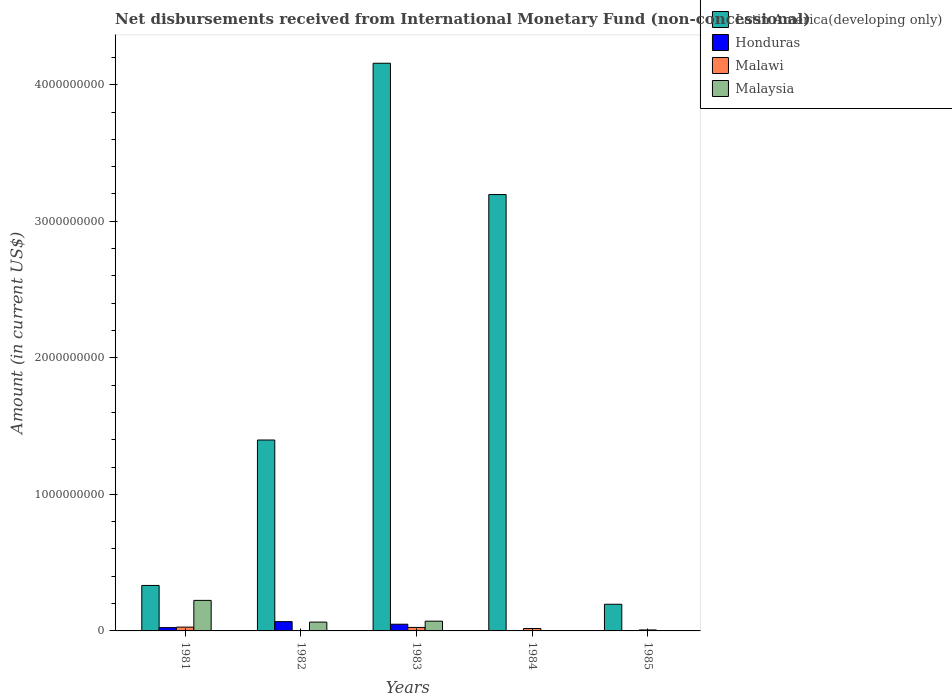How many different coloured bars are there?
Provide a succinct answer. 4. Are the number of bars per tick equal to the number of legend labels?
Your answer should be very brief. No. What is the label of the 1st group of bars from the left?
Provide a short and direct response. 1981. What is the amount of disbursements received from International Monetary Fund in Malaysia in 1982?
Offer a terse response. 6.46e+07. Across all years, what is the maximum amount of disbursements received from International Monetary Fund in Latin America(developing only)?
Provide a short and direct response. 4.16e+09. Across all years, what is the minimum amount of disbursements received from International Monetary Fund in Latin America(developing only)?
Ensure brevity in your answer.  1.95e+08. What is the total amount of disbursements received from International Monetary Fund in Honduras in the graph?
Your response must be concise. 1.41e+08. What is the difference between the amount of disbursements received from International Monetary Fund in Latin America(developing only) in 1982 and that in 1985?
Make the answer very short. 1.20e+09. What is the difference between the amount of disbursements received from International Monetary Fund in Latin America(developing only) in 1983 and the amount of disbursements received from International Monetary Fund in Honduras in 1985?
Ensure brevity in your answer.  4.16e+09. What is the average amount of disbursements received from International Monetary Fund in Malaysia per year?
Provide a short and direct response. 7.19e+07. In the year 1982, what is the difference between the amount of disbursements received from International Monetary Fund in Latin America(developing only) and amount of disbursements received from International Monetary Fund in Malaysia?
Give a very brief answer. 1.33e+09. What is the ratio of the amount of disbursements received from International Monetary Fund in Latin America(developing only) in 1981 to that in 1984?
Offer a terse response. 0.1. Is the amount of disbursements received from International Monetary Fund in Malawi in 1983 less than that in 1984?
Ensure brevity in your answer.  No. What is the difference between the highest and the second highest amount of disbursements received from International Monetary Fund in Latin America(developing only)?
Offer a terse response. 9.61e+08. What is the difference between the highest and the lowest amount of disbursements received from International Monetary Fund in Malaysia?
Your answer should be very brief. 2.24e+08. Is it the case that in every year, the sum of the amount of disbursements received from International Monetary Fund in Malaysia and amount of disbursements received from International Monetary Fund in Malawi is greater than the sum of amount of disbursements received from International Monetary Fund in Honduras and amount of disbursements received from International Monetary Fund in Latin America(developing only)?
Make the answer very short. No. Is it the case that in every year, the sum of the amount of disbursements received from International Monetary Fund in Malawi and amount of disbursements received from International Monetary Fund in Malaysia is greater than the amount of disbursements received from International Monetary Fund in Latin America(developing only)?
Keep it short and to the point. No. Are all the bars in the graph horizontal?
Offer a very short reply. No. How many years are there in the graph?
Make the answer very short. 5. What is the difference between two consecutive major ticks on the Y-axis?
Provide a short and direct response. 1.00e+09. Are the values on the major ticks of Y-axis written in scientific E-notation?
Offer a terse response. No. Does the graph contain any zero values?
Keep it short and to the point. Yes. Does the graph contain grids?
Offer a terse response. No. What is the title of the graph?
Ensure brevity in your answer.  Net disbursements received from International Monetary Fund (non-concessional). Does "Tonga" appear as one of the legend labels in the graph?
Offer a very short reply. No. What is the label or title of the Y-axis?
Make the answer very short. Amount (in current US$). What is the Amount (in current US$) in Latin America(developing only) in 1981?
Keep it short and to the point. 3.33e+08. What is the Amount (in current US$) in Honduras in 1981?
Your answer should be compact. 2.43e+07. What is the Amount (in current US$) of Malawi in 1981?
Provide a short and direct response. 2.79e+07. What is the Amount (in current US$) of Malaysia in 1981?
Offer a terse response. 2.24e+08. What is the Amount (in current US$) in Latin America(developing only) in 1982?
Make the answer very short. 1.40e+09. What is the Amount (in current US$) in Honduras in 1982?
Make the answer very short. 6.81e+07. What is the Amount (in current US$) in Malawi in 1982?
Provide a succinct answer. 0. What is the Amount (in current US$) of Malaysia in 1982?
Your answer should be compact. 6.46e+07. What is the Amount (in current US$) in Latin America(developing only) in 1983?
Give a very brief answer. 4.16e+09. What is the Amount (in current US$) in Honduras in 1983?
Offer a terse response. 4.91e+07. What is the Amount (in current US$) of Malawi in 1983?
Keep it short and to the point. 2.56e+07. What is the Amount (in current US$) of Malaysia in 1983?
Offer a very short reply. 7.14e+07. What is the Amount (in current US$) of Latin America(developing only) in 1984?
Ensure brevity in your answer.  3.20e+09. What is the Amount (in current US$) of Malawi in 1984?
Offer a terse response. 1.78e+07. What is the Amount (in current US$) of Latin America(developing only) in 1985?
Your answer should be compact. 1.95e+08. What is the Amount (in current US$) in Malawi in 1985?
Keep it short and to the point. 7.20e+06. What is the Amount (in current US$) of Malaysia in 1985?
Keep it short and to the point. 0. Across all years, what is the maximum Amount (in current US$) of Latin America(developing only)?
Keep it short and to the point. 4.16e+09. Across all years, what is the maximum Amount (in current US$) in Honduras?
Offer a terse response. 6.81e+07. Across all years, what is the maximum Amount (in current US$) in Malawi?
Offer a very short reply. 2.79e+07. Across all years, what is the maximum Amount (in current US$) in Malaysia?
Your answer should be very brief. 2.24e+08. Across all years, what is the minimum Amount (in current US$) of Latin America(developing only)?
Offer a very short reply. 1.95e+08. Across all years, what is the minimum Amount (in current US$) of Honduras?
Your answer should be compact. 0. Across all years, what is the minimum Amount (in current US$) in Malaysia?
Offer a very short reply. 0. What is the total Amount (in current US$) in Latin America(developing only) in the graph?
Offer a very short reply. 9.28e+09. What is the total Amount (in current US$) in Honduras in the graph?
Your answer should be very brief. 1.41e+08. What is the total Amount (in current US$) of Malawi in the graph?
Give a very brief answer. 7.85e+07. What is the total Amount (in current US$) of Malaysia in the graph?
Your response must be concise. 3.60e+08. What is the difference between the Amount (in current US$) of Latin America(developing only) in 1981 and that in 1982?
Your answer should be very brief. -1.07e+09. What is the difference between the Amount (in current US$) in Honduras in 1981 and that in 1982?
Ensure brevity in your answer.  -4.38e+07. What is the difference between the Amount (in current US$) of Malaysia in 1981 and that in 1982?
Your answer should be very brief. 1.59e+08. What is the difference between the Amount (in current US$) of Latin America(developing only) in 1981 and that in 1983?
Your response must be concise. -3.82e+09. What is the difference between the Amount (in current US$) in Honduras in 1981 and that in 1983?
Offer a very short reply. -2.48e+07. What is the difference between the Amount (in current US$) in Malawi in 1981 and that in 1983?
Keep it short and to the point. 2.30e+06. What is the difference between the Amount (in current US$) in Malaysia in 1981 and that in 1983?
Your answer should be compact. 1.52e+08. What is the difference between the Amount (in current US$) of Latin America(developing only) in 1981 and that in 1984?
Your answer should be compact. -2.86e+09. What is the difference between the Amount (in current US$) in Malawi in 1981 and that in 1984?
Give a very brief answer. 1.01e+07. What is the difference between the Amount (in current US$) in Latin America(developing only) in 1981 and that in 1985?
Offer a terse response. 1.38e+08. What is the difference between the Amount (in current US$) in Malawi in 1981 and that in 1985?
Make the answer very short. 2.07e+07. What is the difference between the Amount (in current US$) in Latin America(developing only) in 1982 and that in 1983?
Offer a terse response. -2.76e+09. What is the difference between the Amount (in current US$) in Honduras in 1982 and that in 1983?
Make the answer very short. 1.90e+07. What is the difference between the Amount (in current US$) in Malaysia in 1982 and that in 1983?
Make the answer very short. -6.80e+06. What is the difference between the Amount (in current US$) in Latin America(developing only) in 1982 and that in 1984?
Your response must be concise. -1.80e+09. What is the difference between the Amount (in current US$) of Latin America(developing only) in 1982 and that in 1985?
Give a very brief answer. 1.20e+09. What is the difference between the Amount (in current US$) in Latin America(developing only) in 1983 and that in 1984?
Ensure brevity in your answer.  9.61e+08. What is the difference between the Amount (in current US$) of Malawi in 1983 and that in 1984?
Your answer should be compact. 7.80e+06. What is the difference between the Amount (in current US$) in Latin America(developing only) in 1983 and that in 1985?
Offer a terse response. 3.96e+09. What is the difference between the Amount (in current US$) in Malawi in 1983 and that in 1985?
Provide a short and direct response. 1.84e+07. What is the difference between the Amount (in current US$) of Latin America(developing only) in 1984 and that in 1985?
Ensure brevity in your answer.  3.00e+09. What is the difference between the Amount (in current US$) in Malawi in 1984 and that in 1985?
Your answer should be compact. 1.06e+07. What is the difference between the Amount (in current US$) of Latin America(developing only) in 1981 and the Amount (in current US$) of Honduras in 1982?
Keep it short and to the point. 2.65e+08. What is the difference between the Amount (in current US$) in Latin America(developing only) in 1981 and the Amount (in current US$) in Malaysia in 1982?
Provide a succinct answer. 2.68e+08. What is the difference between the Amount (in current US$) in Honduras in 1981 and the Amount (in current US$) in Malaysia in 1982?
Offer a terse response. -4.03e+07. What is the difference between the Amount (in current US$) in Malawi in 1981 and the Amount (in current US$) in Malaysia in 1982?
Make the answer very short. -3.67e+07. What is the difference between the Amount (in current US$) of Latin America(developing only) in 1981 and the Amount (in current US$) of Honduras in 1983?
Offer a terse response. 2.84e+08. What is the difference between the Amount (in current US$) in Latin America(developing only) in 1981 and the Amount (in current US$) in Malawi in 1983?
Give a very brief answer. 3.07e+08. What is the difference between the Amount (in current US$) in Latin America(developing only) in 1981 and the Amount (in current US$) in Malaysia in 1983?
Provide a short and direct response. 2.62e+08. What is the difference between the Amount (in current US$) of Honduras in 1981 and the Amount (in current US$) of Malawi in 1983?
Offer a terse response. -1.30e+06. What is the difference between the Amount (in current US$) of Honduras in 1981 and the Amount (in current US$) of Malaysia in 1983?
Provide a succinct answer. -4.71e+07. What is the difference between the Amount (in current US$) in Malawi in 1981 and the Amount (in current US$) in Malaysia in 1983?
Provide a short and direct response. -4.35e+07. What is the difference between the Amount (in current US$) in Latin America(developing only) in 1981 and the Amount (in current US$) in Malawi in 1984?
Your answer should be very brief. 3.15e+08. What is the difference between the Amount (in current US$) in Honduras in 1981 and the Amount (in current US$) in Malawi in 1984?
Your answer should be very brief. 6.50e+06. What is the difference between the Amount (in current US$) of Latin America(developing only) in 1981 and the Amount (in current US$) of Malawi in 1985?
Provide a succinct answer. 3.26e+08. What is the difference between the Amount (in current US$) of Honduras in 1981 and the Amount (in current US$) of Malawi in 1985?
Your response must be concise. 1.71e+07. What is the difference between the Amount (in current US$) in Latin America(developing only) in 1982 and the Amount (in current US$) in Honduras in 1983?
Your response must be concise. 1.35e+09. What is the difference between the Amount (in current US$) of Latin America(developing only) in 1982 and the Amount (in current US$) of Malawi in 1983?
Your answer should be compact. 1.37e+09. What is the difference between the Amount (in current US$) in Latin America(developing only) in 1982 and the Amount (in current US$) in Malaysia in 1983?
Ensure brevity in your answer.  1.33e+09. What is the difference between the Amount (in current US$) of Honduras in 1982 and the Amount (in current US$) of Malawi in 1983?
Your answer should be compact. 4.25e+07. What is the difference between the Amount (in current US$) in Honduras in 1982 and the Amount (in current US$) in Malaysia in 1983?
Offer a terse response. -3.30e+06. What is the difference between the Amount (in current US$) in Latin America(developing only) in 1982 and the Amount (in current US$) in Malawi in 1984?
Give a very brief answer. 1.38e+09. What is the difference between the Amount (in current US$) in Honduras in 1982 and the Amount (in current US$) in Malawi in 1984?
Provide a succinct answer. 5.03e+07. What is the difference between the Amount (in current US$) of Latin America(developing only) in 1982 and the Amount (in current US$) of Malawi in 1985?
Provide a short and direct response. 1.39e+09. What is the difference between the Amount (in current US$) in Honduras in 1982 and the Amount (in current US$) in Malawi in 1985?
Your answer should be very brief. 6.09e+07. What is the difference between the Amount (in current US$) in Latin America(developing only) in 1983 and the Amount (in current US$) in Malawi in 1984?
Your answer should be very brief. 4.14e+09. What is the difference between the Amount (in current US$) of Honduras in 1983 and the Amount (in current US$) of Malawi in 1984?
Provide a short and direct response. 3.13e+07. What is the difference between the Amount (in current US$) of Latin America(developing only) in 1983 and the Amount (in current US$) of Malawi in 1985?
Make the answer very short. 4.15e+09. What is the difference between the Amount (in current US$) in Honduras in 1983 and the Amount (in current US$) in Malawi in 1985?
Your answer should be compact. 4.19e+07. What is the difference between the Amount (in current US$) of Latin America(developing only) in 1984 and the Amount (in current US$) of Malawi in 1985?
Offer a terse response. 3.19e+09. What is the average Amount (in current US$) in Latin America(developing only) per year?
Give a very brief answer. 1.86e+09. What is the average Amount (in current US$) of Honduras per year?
Give a very brief answer. 2.83e+07. What is the average Amount (in current US$) in Malawi per year?
Your response must be concise. 1.57e+07. What is the average Amount (in current US$) of Malaysia per year?
Give a very brief answer. 7.19e+07. In the year 1981, what is the difference between the Amount (in current US$) in Latin America(developing only) and Amount (in current US$) in Honduras?
Your answer should be very brief. 3.09e+08. In the year 1981, what is the difference between the Amount (in current US$) of Latin America(developing only) and Amount (in current US$) of Malawi?
Your answer should be very brief. 3.05e+08. In the year 1981, what is the difference between the Amount (in current US$) of Latin America(developing only) and Amount (in current US$) of Malaysia?
Provide a succinct answer. 1.09e+08. In the year 1981, what is the difference between the Amount (in current US$) in Honduras and Amount (in current US$) in Malawi?
Give a very brief answer. -3.60e+06. In the year 1981, what is the difference between the Amount (in current US$) in Honduras and Amount (in current US$) in Malaysia?
Your answer should be compact. -1.99e+08. In the year 1981, what is the difference between the Amount (in current US$) in Malawi and Amount (in current US$) in Malaysia?
Provide a short and direct response. -1.96e+08. In the year 1982, what is the difference between the Amount (in current US$) in Latin America(developing only) and Amount (in current US$) in Honduras?
Offer a very short reply. 1.33e+09. In the year 1982, what is the difference between the Amount (in current US$) in Latin America(developing only) and Amount (in current US$) in Malaysia?
Your answer should be compact. 1.33e+09. In the year 1982, what is the difference between the Amount (in current US$) of Honduras and Amount (in current US$) of Malaysia?
Offer a very short reply. 3.50e+06. In the year 1983, what is the difference between the Amount (in current US$) in Latin America(developing only) and Amount (in current US$) in Honduras?
Give a very brief answer. 4.11e+09. In the year 1983, what is the difference between the Amount (in current US$) in Latin America(developing only) and Amount (in current US$) in Malawi?
Offer a very short reply. 4.13e+09. In the year 1983, what is the difference between the Amount (in current US$) of Latin America(developing only) and Amount (in current US$) of Malaysia?
Your answer should be very brief. 4.09e+09. In the year 1983, what is the difference between the Amount (in current US$) of Honduras and Amount (in current US$) of Malawi?
Provide a short and direct response. 2.35e+07. In the year 1983, what is the difference between the Amount (in current US$) of Honduras and Amount (in current US$) of Malaysia?
Give a very brief answer. -2.23e+07. In the year 1983, what is the difference between the Amount (in current US$) in Malawi and Amount (in current US$) in Malaysia?
Offer a terse response. -4.58e+07. In the year 1984, what is the difference between the Amount (in current US$) of Latin America(developing only) and Amount (in current US$) of Malawi?
Ensure brevity in your answer.  3.18e+09. In the year 1985, what is the difference between the Amount (in current US$) in Latin America(developing only) and Amount (in current US$) in Malawi?
Your answer should be very brief. 1.88e+08. What is the ratio of the Amount (in current US$) of Latin America(developing only) in 1981 to that in 1982?
Offer a very short reply. 0.24. What is the ratio of the Amount (in current US$) of Honduras in 1981 to that in 1982?
Your answer should be very brief. 0.36. What is the ratio of the Amount (in current US$) of Malaysia in 1981 to that in 1982?
Your answer should be very brief. 3.46. What is the ratio of the Amount (in current US$) in Latin America(developing only) in 1981 to that in 1983?
Ensure brevity in your answer.  0.08. What is the ratio of the Amount (in current US$) of Honduras in 1981 to that in 1983?
Your answer should be compact. 0.5. What is the ratio of the Amount (in current US$) in Malawi in 1981 to that in 1983?
Give a very brief answer. 1.09. What is the ratio of the Amount (in current US$) in Malaysia in 1981 to that in 1983?
Give a very brief answer. 3.13. What is the ratio of the Amount (in current US$) in Latin America(developing only) in 1981 to that in 1984?
Provide a short and direct response. 0.1. What is the ratio of the Amount (in current US$) of Malawi in 1981 to that in 1984?
Offer a very short reply. 1.57. What is the ratio of the Amount (in current US$) of Latin America(developing only) in 1981 to that in 1985?
Offer a very short reply. 1.71. What is the ratio of the Amount (in current US$) in Malawi in 1981 to that in 1985?
Make the answer very short. 3.88. What is the ratio of the Amount (in current US$) in Latin America(developing only) in 1982 to that in 1983?
Keep it short and to the point. 0.34. What is the ratio of the Amount (in current US$) in Honduras in 1982 to that in 1983?
Your response must be concise. 1.39. What is the ratio of the Amount (in current US$) in Malaysia in 1982 to that in 1983?
Your answer should be compact. 0.9. What is the ratio of the Amount (in current US$) in Latin America(developing only) in 1982 to that in 1984?
Offer a very short reply. 0.44. What is the ratio of the Amount (in current US$) of Latin America(developing only) in 1982 to that in 1985?
Your answer should be compact. 7.16. What is the ratio of the Amount (in current US$) of Latin America(developing only) in 1983 to that in 1984?
Ensure brevity in your answer.  1.3. What is the ratio of the Amount (in current US$) of Malawi in 1983 to that in 1984?
Provide a short and direct response. 1.44. What is the ratio of the Amount (in current US$) in Latin America(developing only) in 1983 to that in 1985?
Offer a very short reply. 21.29. What is the ratio of the Amount (in current US$) of Malawi in 1983 to that in 1985?
Give a very brief answer. 3.56. What is the ratio of the Amount (in current US$) of Latin America(developing only) in 1984 to that in 1985?
Give a very brief answer. 16.37. What is the ratio of the Amount (in current US$) in Malawi in 1984 to that in 1985?
Provide a short and direct response. 2.47. What is the difference between the highest and the second highest Amount (in current US$) of Latin America(developing only)?
Make the answer very short. 9.61e+08. What is the difference between the highest and the second highest Amount (in current US$) in Honduras?
Your answer should be compact. 1.90e+07. What is the difference between the highest and the second highest Amount (in current US$) of Malawi?
Offer a very short reply. 2.30e+06. What is the difference between the highest and the second highest Amount (in current US$) of Malaysia?
Make the answer very short. 1.52e+08. What is the difference between the highest and the lowest Amount (in current US$) of Latin America(developing only)?
Keep it short and to the point. 3.96e+09. What is the difference between the highest and the lowest Amount (in current US$) in Honduras?
Give a very brief answer. 6.81e+07. What is the difference between the highest and the lowest Amount (in current US$) of Malawi?
Keep it short and to the point. 2.79e+07. What is the difference between the highest and the lowest Amount (in current US$) of Malaysia?
Keep it short and to the point. 2.24e+08. 